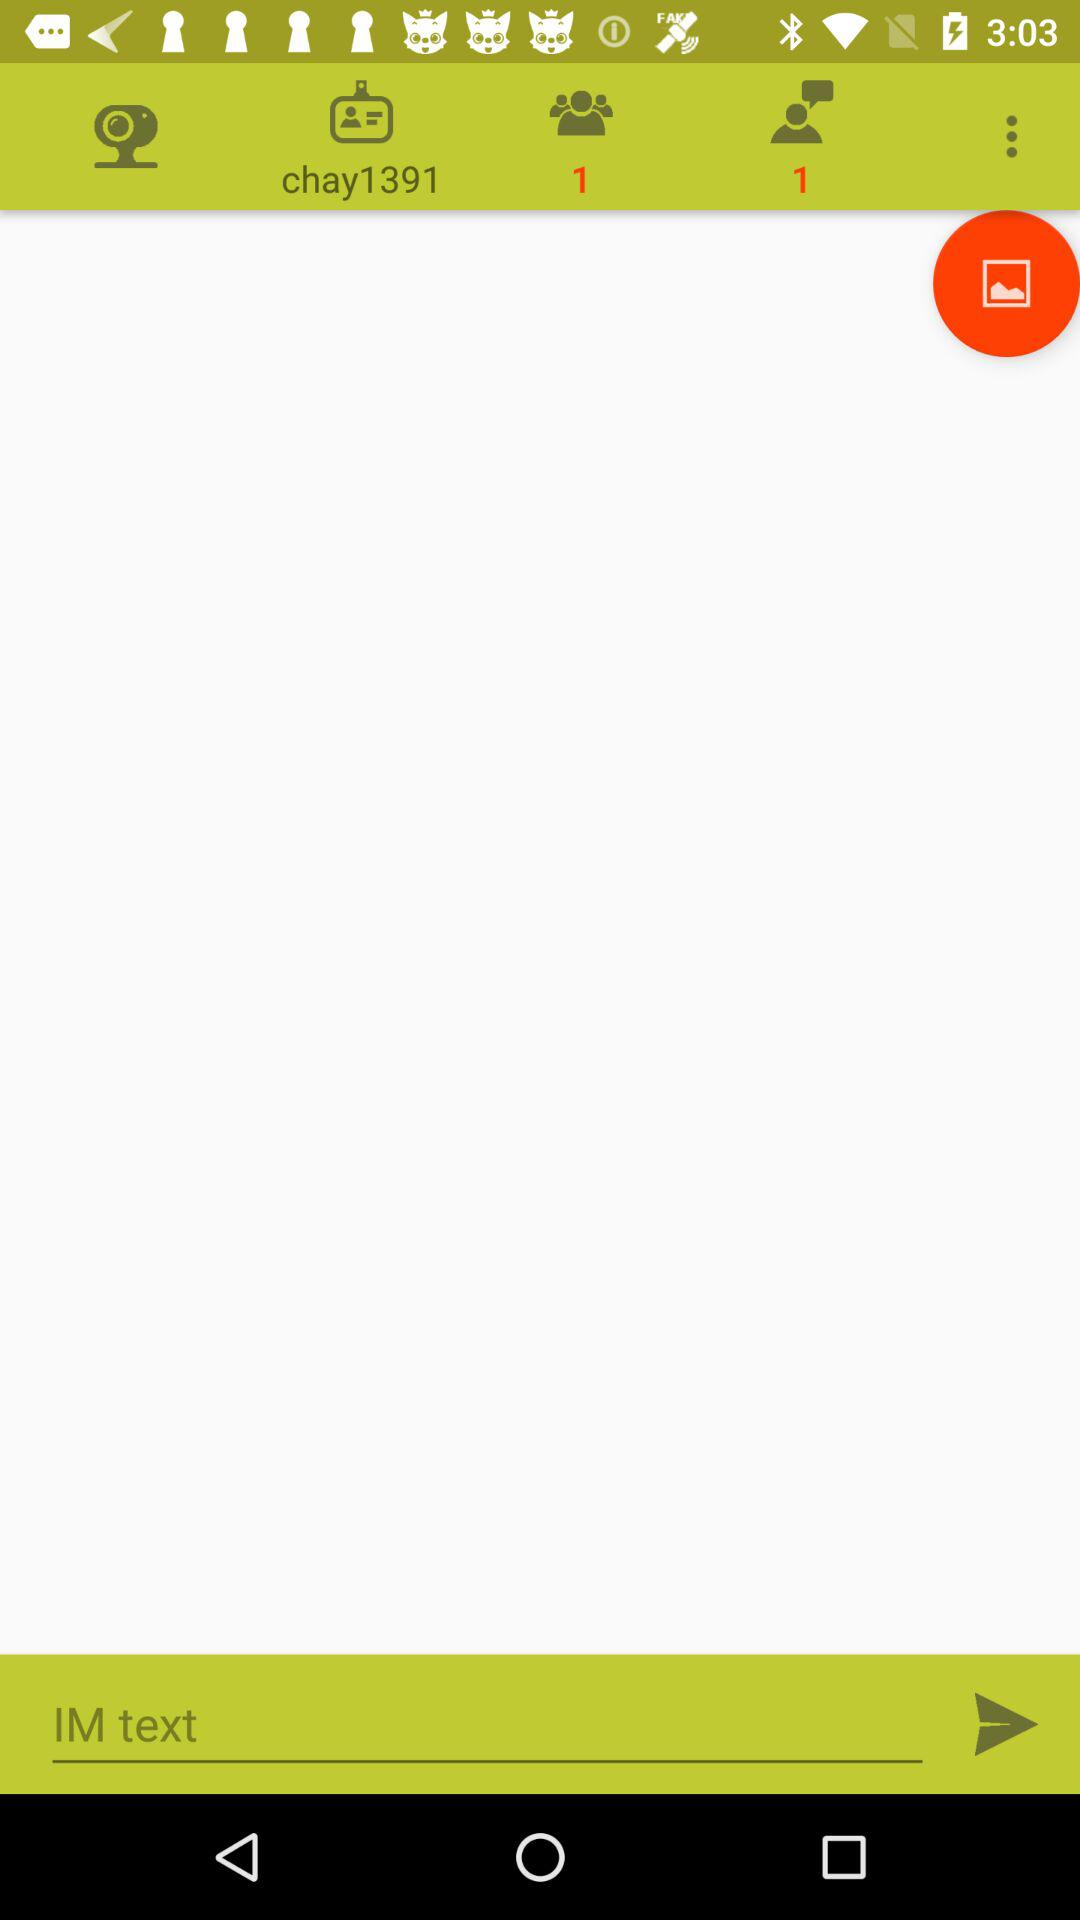What is the number of the request? The number of the request is 1. 